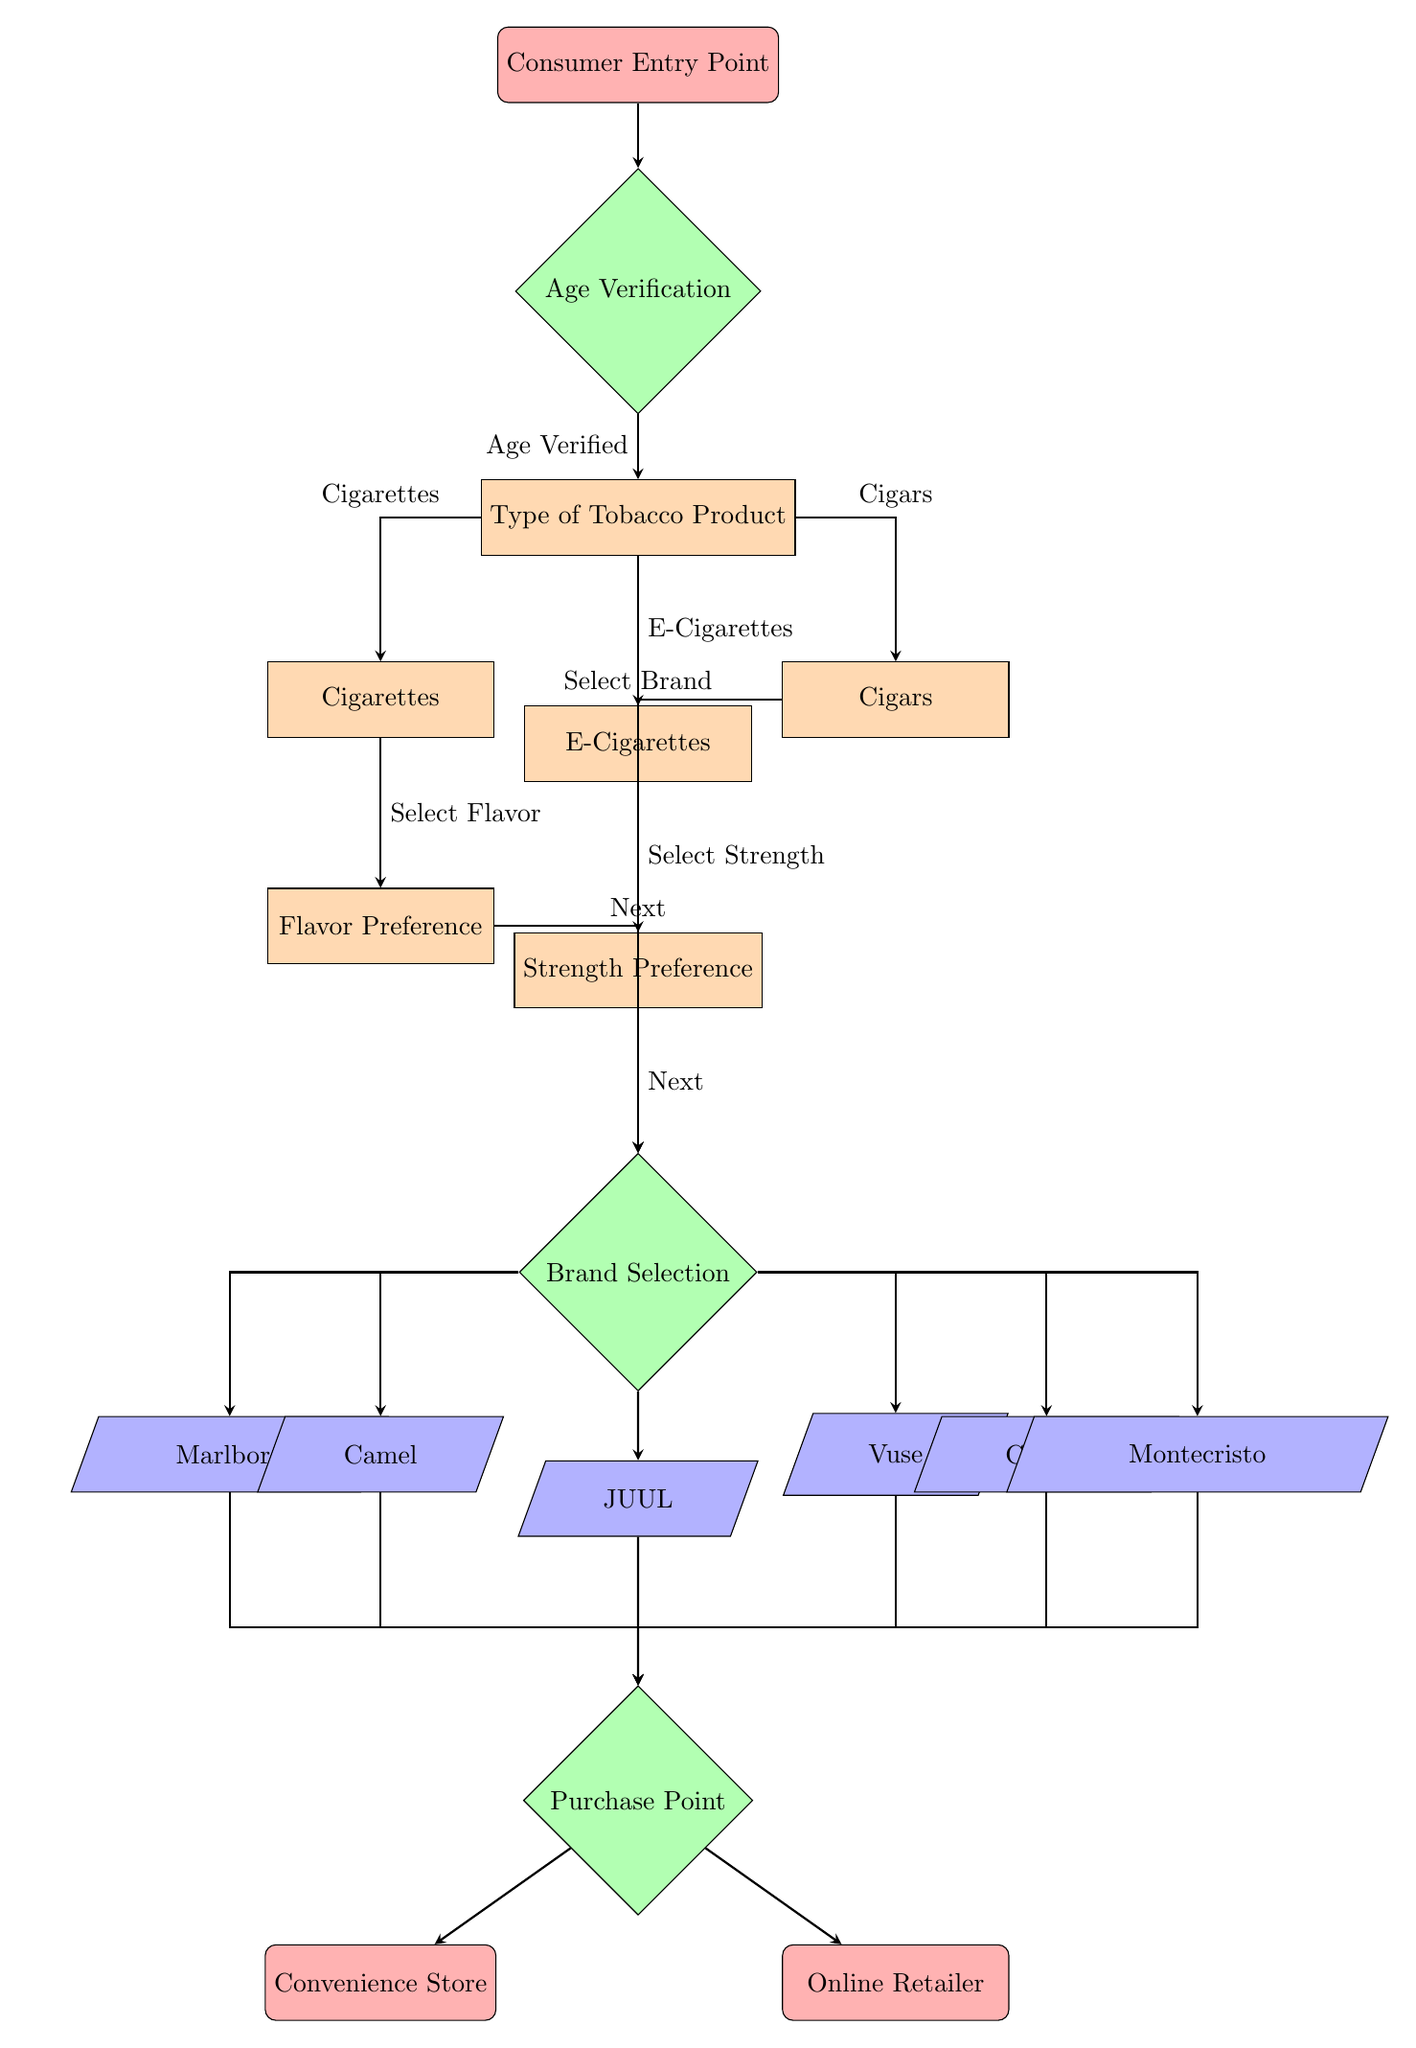What is the first step of the consumer experience flow? The first step in the flowchart is represented by the node labeled "Consumer Entry Point," which indicates where the consumer initially interacts with the process.
Answer: Consumer Entry Point How many types of tobacco products are listed in the flowchart? The flowchart includes three types of tobacco products: Cigarettes, E-Cigarettes, and Cigars. Thus, the total number is three.
Answer: 3 What decision follows the "Strength Preference"? After making a "Strength Preference," the next decision node is "Brand Selection," where the consumer decides on the brand of the selected product.
Answer: Brand Selection If a consumer chooses "Cigars," what is the immediate next step? Upon selecting "Cigars," the next step is to select a brand, leading to the "Brand Selection" decision node, where various cigar brands are presented.
Answer: Brand Selection What are two purchase points available in the flow? The flowchart indicates two points where the consumer can purchase their selected tobacco product: "Convenience Store" and "Online Retailer."
Answer: Convenience Store, Online Retailer What is the last decision made in the selection process? The last decision made in the flow is the "Purchase Point," which determines where the consumer will buy their chosen product after making all prior selections.
Answer: Purchase Point Which tobacco product requires a "Flavor Preference"? The product that requires a "Flavor Preference" is "Cigarettes," as indicated in the flowchart, where consumers can choose their preferred flavor before selecting a brand.
Answer: Cigarettes What type of node follows "Cigars" in the process? Following "Cigars," the flowchart presents a decision node labeled "Brand Selection," which leads consumers to select among different cigar brands after indicating their product choice.
Answer: Brand Selection Which brands are linked to the "Brand Selection" decision for e-cigarettes? The brands linked to the "Brand Selection" decision for e-cigarettes include JUUL and Vuse, each presented in different paths directly connected to the brand decision node.
Answer: JUUL, Vuse 